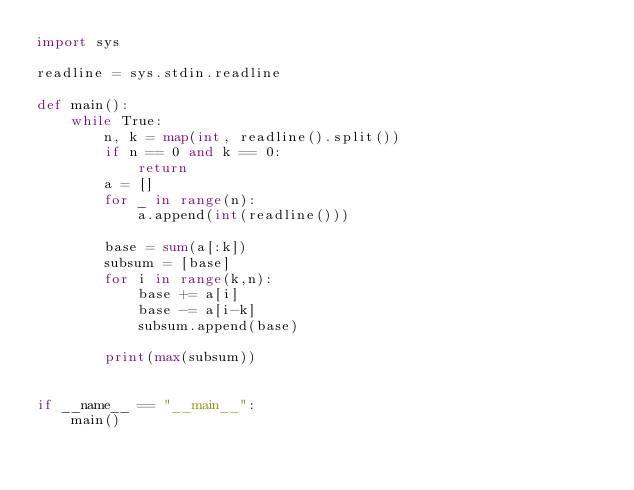Convert code to text. <code><loc_0><loc_0><loc_500><loc_500><_Python_>import sys

readline = sys.stdin.readline

def main():
    while True:
        n, k = map(int, readline().split())
        if n == 0 and k == 0:
            return
        a = []
        for _ in range(n):
            a.append(int(readline()))

        base = sum(a[:k])
        subsum = [base]
        for i in range(k,n):
            base += a[i]
            base -= a[i-k]
            subsum.append(base)

        print(max(subsum))


if __name__ == "__main__":
    main()

</code> 